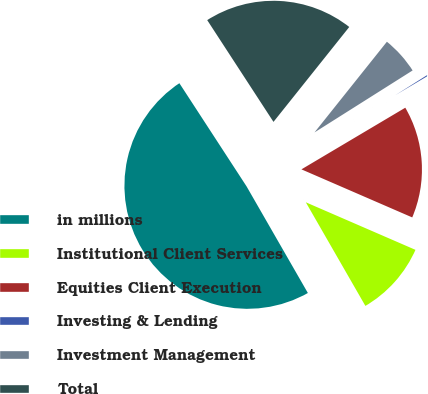<chart> <loc_0><loc_0><loc_500><loc_500><pie_chart><fcel>in millions<fcel>Institutional Client Services<fcel>Equities Client Execution<fcel>Investing & Lending<fcel>Investment Management<fcel>Total<nl><fcel>49.12%<fcel>10.18%<fcel>15.04%<fcel>0.44%<fcel>5.31%<fcel>19.91%<nl></chart> 